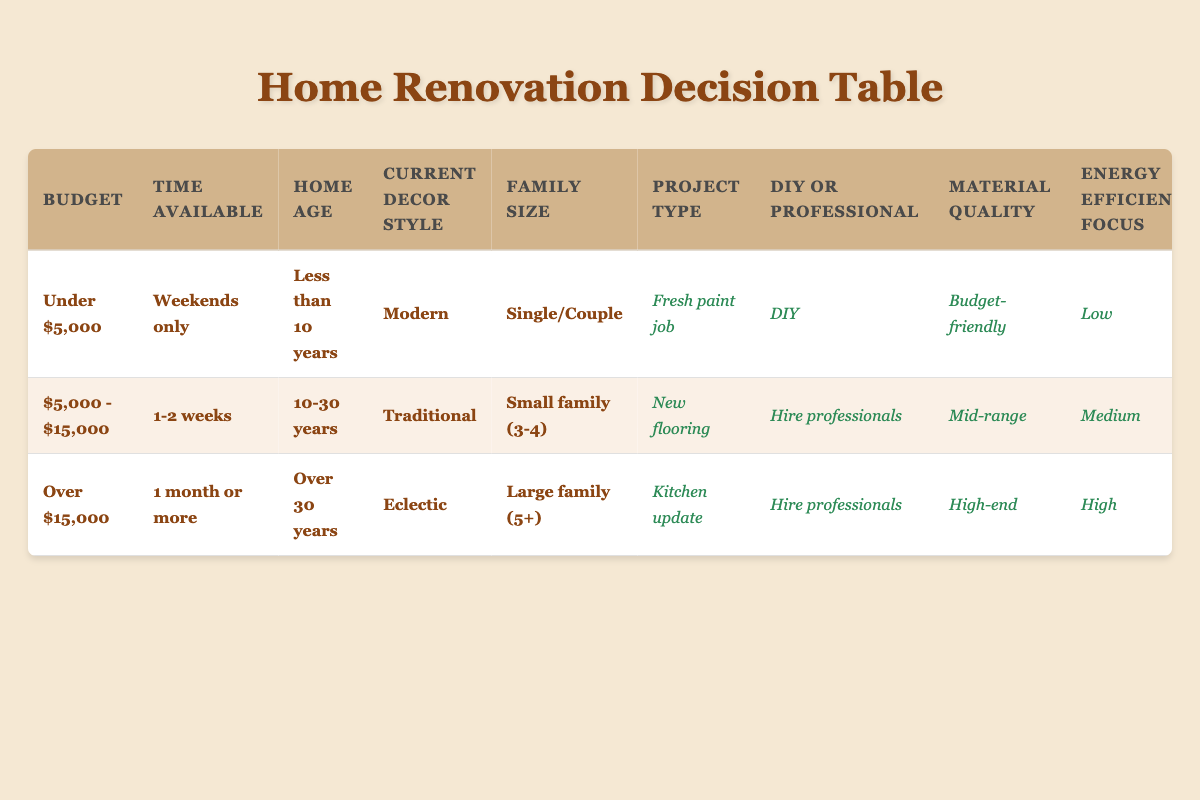What renovation project is suggested for a small family with a budget of between $5,000 and $15,000? In the table, we look for the row where the budget is "$5,000 - $15,000" and family size is "Small family (3-4)". This corresponds to the project type "New flooring".
Answer: New flooring Is a permit required for a kitchen update? We need to check the row where the project type is "Kitchen update". According to the table, the "Permit Required" column for that row indicates "Yes".
Answer: Yes What is the recommended material quality for a DIY project with a budget under $5,000? We search for the row where the budget is "Under $5,000" and "DIY" is selected. This row shows that the recommended material quality is "Budget-friendly".
Answer: Budget-friendly How many projects in this table require hiring professionals? We look through all the actions in the table and identify those entries marked as "Hire professionals". In total, there are two entries for hiring professionals: one for "New flooring" and one for "Kitchen update".
Answer: Two If you focus on energy efficiency for a bathroom remodel, what budget would you likely need? The table does not list a bathroom remodel specifically, but it suggests that "Kitchen update" is available for "Over $15,000" budget while having a "High" energy efficiency focus. Thus, we can infer a large budget is required for a remodel that emphasizes high energy efficiency, suggesting a higher budget around "Over $15,000".
Answer: Over $15,000 For a house over 30 years old and a large family, what project is recommended? Checking the row for "Over 30 years" age and "Large family (5+)", we find that the suggested project type is "Kitchen update".
Answer: Kitchen update Does having a modern decor style influence the need for a permit in a DIY project under $5,000? For a "Modern" decor style with a "DIY" option and a budget "Under $5,000", the table indicates that a permit is not needed, as stated in the relevant row.
Answer: No What is the energy efficiency focus for a home renovation project that involves landscaping? The table does not specifically mention landscaping in any of the provided rules, indicating that it likely doesn't have a designated energy efficiency focus. Based on what's listed, landscaping is also not part of the rules; hence we cannot ascertain an energy efficiency focus for it.
Answer: Not applicable 